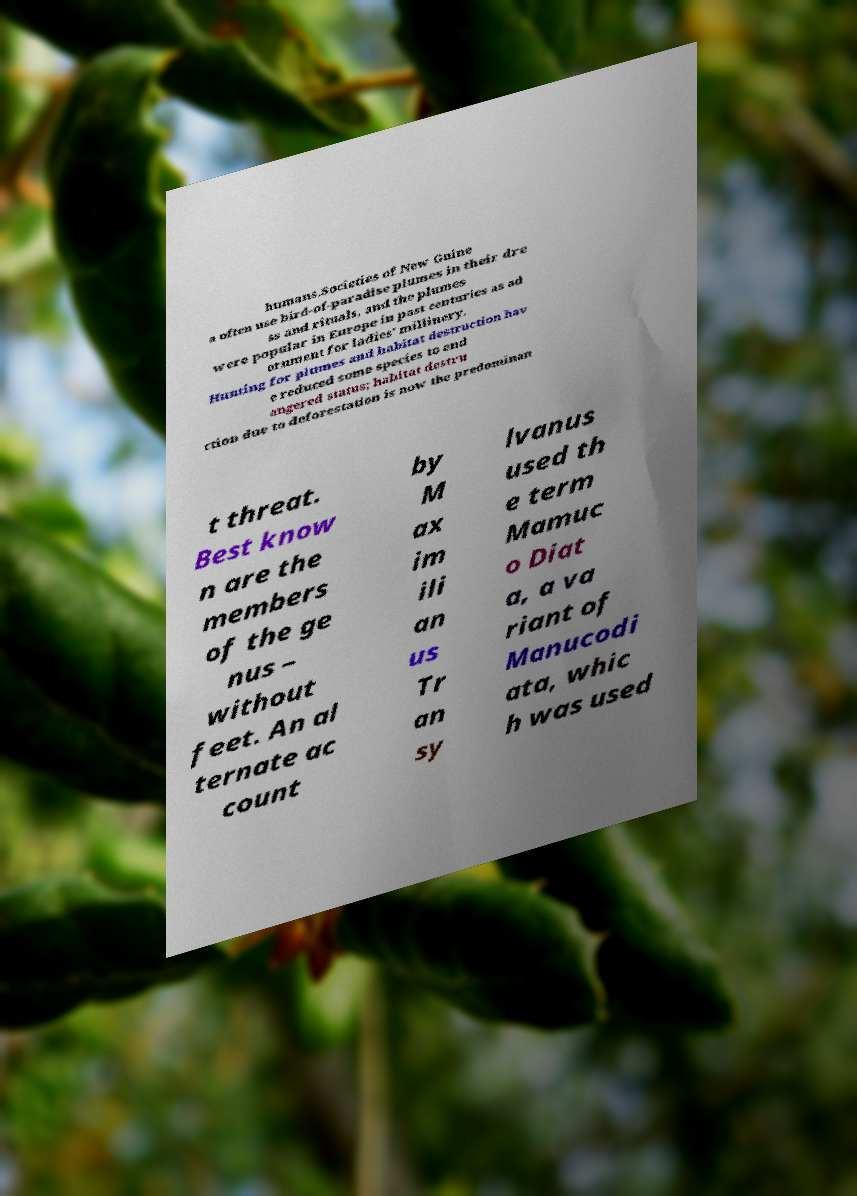Please read and relay the text visible in this image. What does it say? humans.Societies of New Guine a often use bird-of-paradise plumes in their dre ss and rituals, and the plumes were popular in Europe in past centuries as ad ornment for ladies' millinery. Hunting for plumes and habitat destruction hav e reduced some species to end angered status; habitat destru ction due to deforestation is now the predominan t threat. Best know n are the members of the ge nus – without feet. An al ternate ac count by M ax im ili an us Tr an sy lvanus used th e term Mamuc o Diat a, a va riant of Manucodi ata, whic h was used 